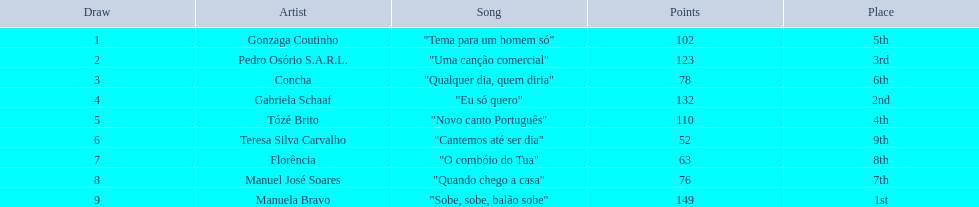Can a melody called "eu so quero" be found in the table? "Eu só quero". Who is responsible for singing that composition? Gabriela Schaaf. 